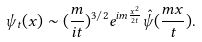<formula> <loc_0><loc_0><loc_500><loc_500>\psi _ { t } ( { x } ) \sim ( \frac { m } { i t } ) ^ { 3 / 2 } e ^ { i m \frac { x ^ { 2 } } { 2 t } } \hat { \psi } ( \frac { m { x } } { t } ) .</formula> 